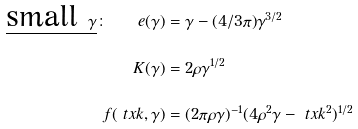<formula> <loc_0><loc_0><loc_500><loc_500>\underline { \text {small } \gamma } \colon \quad e ( \gamma ) & = \gamma - ( 4 / 3 \pi ) \gamma ^ { 3 / 2 } \\ K ( \gamma ) & = 2 \rho \gamma ^ { 1 / 2 } \\ f ( \ t x k , \gamma ) & = ( 2 \pi \rho \gamma ) ^ { - 1 } ( 4 \rho ^ { 2 } \gamma - \ t x k ^ { 2 } ) ^ { 1 / 2 }</formula> 